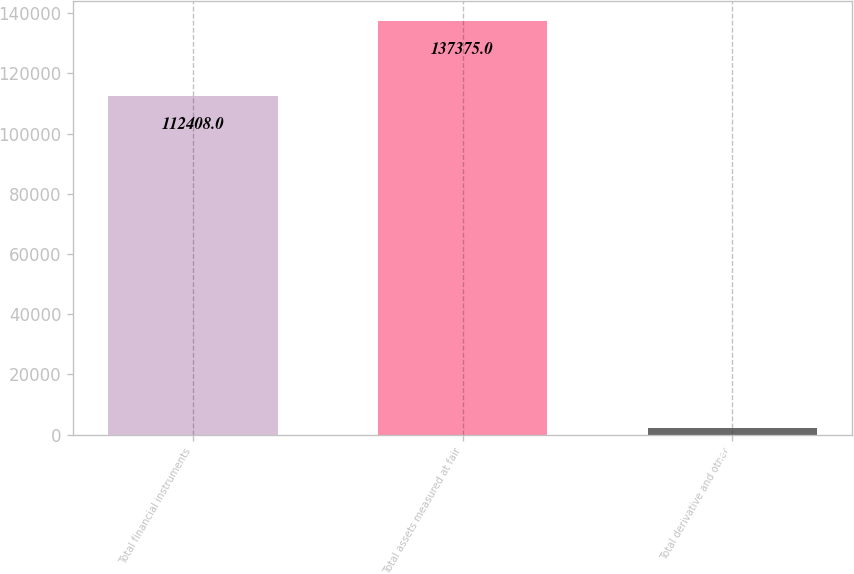<chart> <loc_0><loc_0><loc_500><loc_500><bar_chart><fcel>Total financial instruments<fcel>Total assets measured at fair<fcel>Total derivative and other<nl><fcel>112408<fcel>137375<fcel>2105<nl></chart> 